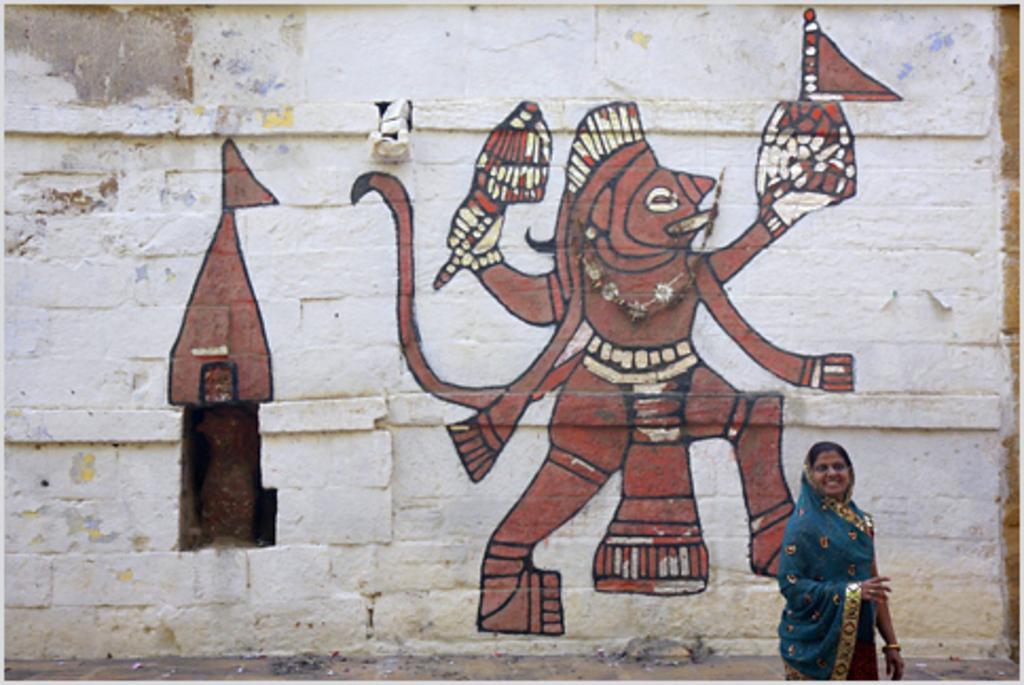Can you describe this image briefly? In this picture I can see the painting on the wall. In the bottom right corner there is a woman who is wearing sari. 